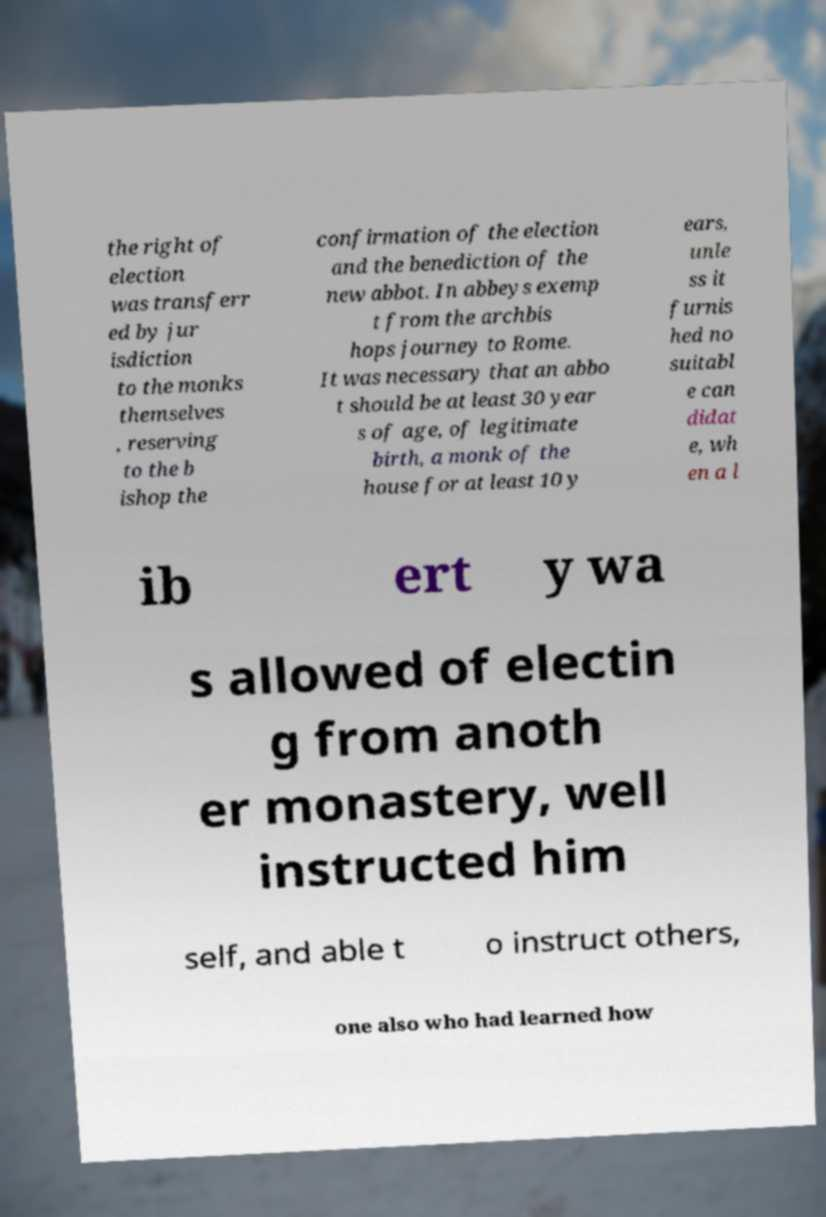I need the written content from this picture converted into text. Can you do that? the right of election was transferr ed by jur isdiction to the monks themselves , reserving to the b ishop the confirmation of the election and the benediction of the new abbot. In abbeys exemp t from the archbis hops journey to Rome. It was necessary that an abbo t should be at least 30 year s of age, of legitimate birth, a monk of the house for at least 10 y ears, unle ss it furnis hed no suitabl e can didat e, wh en a l ib ert y wa s allowed of electin g from anoth er monastery, well instructed him self, and able t o instruct others, one also who had learned how 